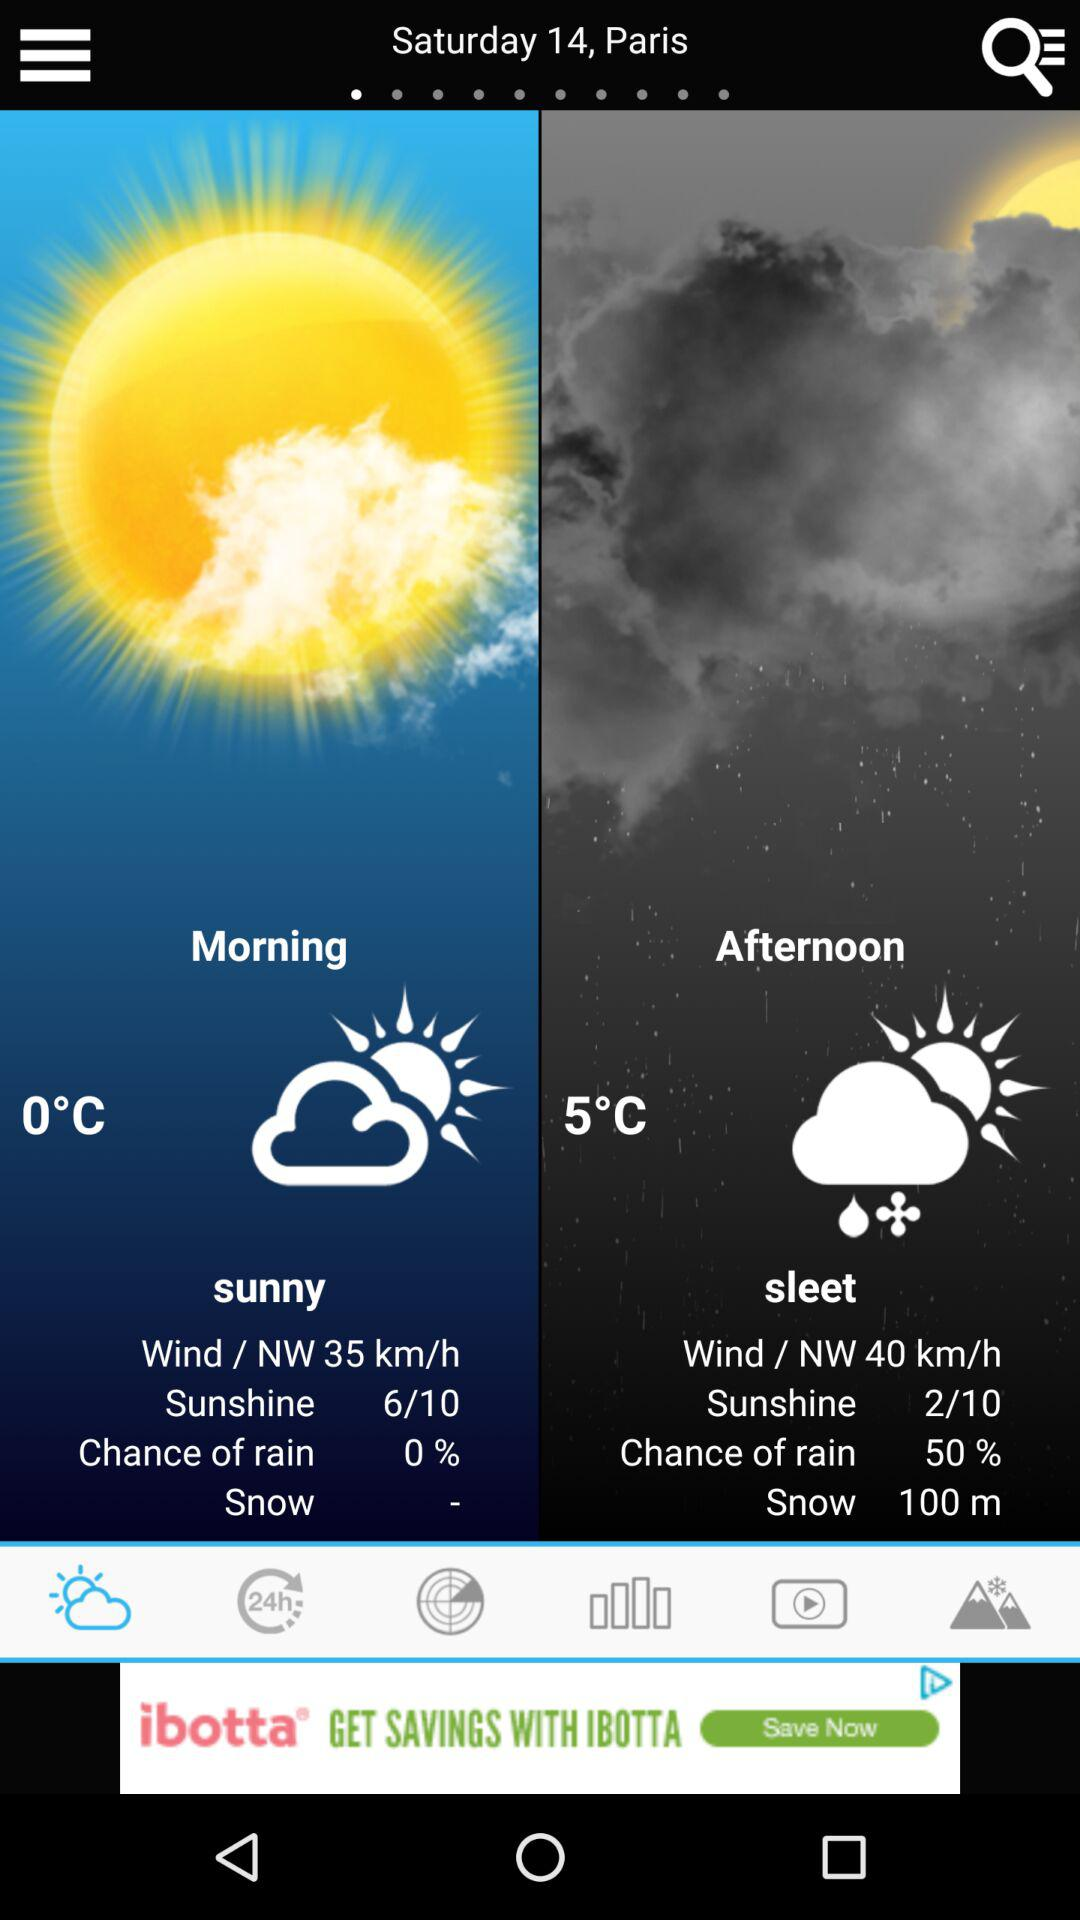At what speed will the wind blow in the afternoon? The wind will blow at a speed of 40 km/h in the afternoon. 